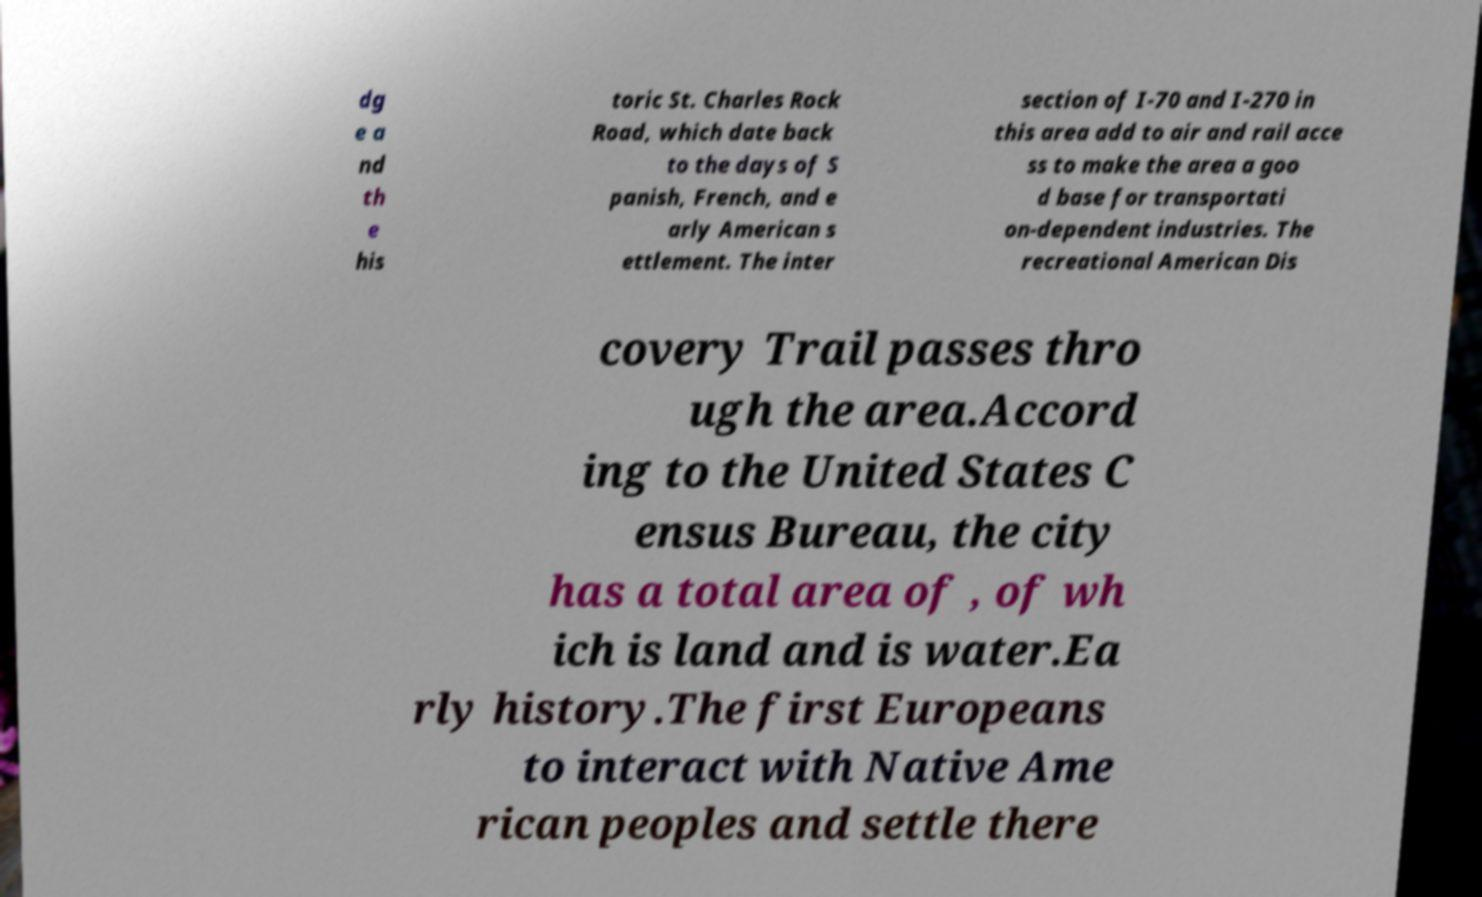Can you read and provide the text displayed in the image?This photo seems to have some interesting text. Can you extract and type it out for me? dg e a nd th e his toric St. Charles Rock Road, which date back to the days of S panish, French, and e arly American s ettlement. The inter section of I-70 and I-270 in this area add to air and rail acce ss to make the area a goo d base for transportati on-dependent industries. The recreational American Dis covery Trail passes thro ugh the area.Accord ing to the United States C ensus Bureau, the city has a total area of , of wh ich is land and is water.Ea rly history.The first Europeans to interact with Native Ame rican peoples and settle there 